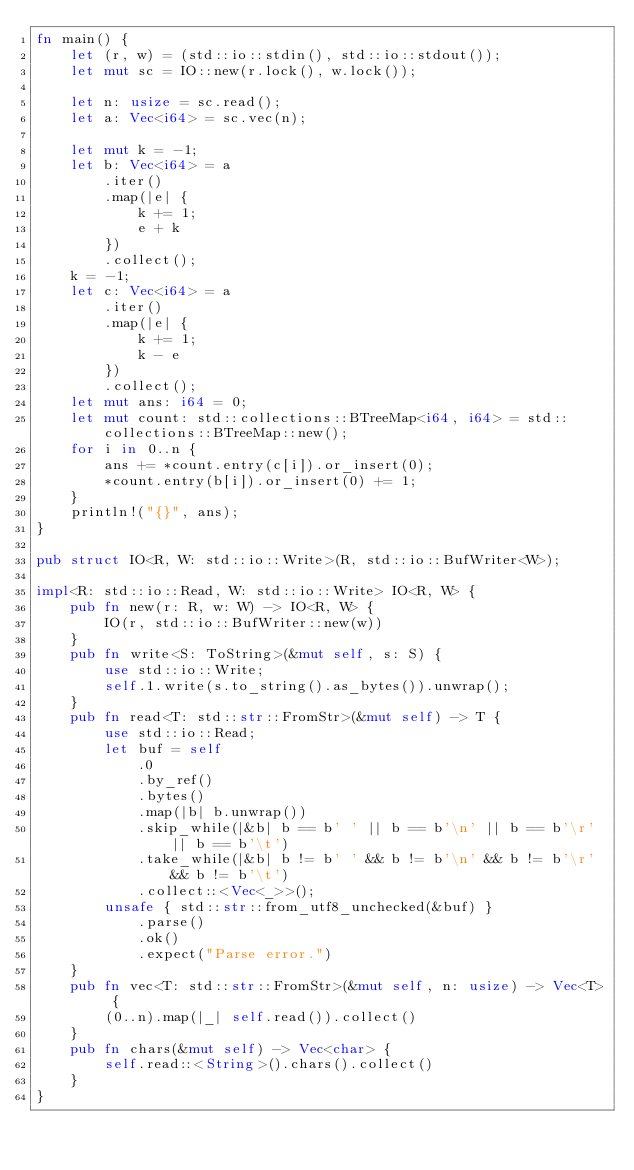<code> <loc_0><loc_0><loc_500><loc_500><_Rust_>fn main() {
    let (r, w) = (std::io::stdin(), std::io::stdout());
    let mut sc = IO::new(r.lock(), w.lock());

    let n: usize = sc.read();
    let a: Vec<i64> = sc.vec(n);

    let mut k = -1;
    let b: Vec<i64> = a
        .iter()
        .map(|e| {
            k += 1;
            e + k
        })
        .collect();
    k = -1;
    let c: Vec<i64> = a
        .iter()
        .map(|e| {
            k += 1;
            k - e
        })
        .collect();
    let mut ans: i64 = 0;
    let mut count: std::collections::BTreeMap<i64, i64> = std::collections::BTreeMap::new();
    for i in 0..n {
        ans += *count.entry(c[i]).or_insert(0);
        *count.entry(b[i]).or_insert(0) += 1;
    }
    println!("{}", ans);
}

pub struct IO<R, W: std::io::Write>(R, std::io::BufWriter<W>);

impl<R: std::io::Read, W: std::io::Write> IO<R, W> {
    pub fn new(r: R, w: W) -> IO<R, W> {
        IO(r, std::io::BufWriter::new(w))
    }
    pub fn write<S: ToString>(&mut self, s: S) {
        use std::io::Write;
        self.1.write(s.to_string().as_bytes()).unwrap();
    }
    pub fn read<T: std::str::FromStr>(&mut self) -> T {
        use std::io::Read;
        let buf = self
            .0
            .by_ref()
            .bytes()
            .map(|b| b.unwrap())
            .skip_while(|&b| b == b' ' || b == b'\n' || b == b'\r' || b == b'\t')
            .take_while(|&b| b != b' ' && b != b'\n' && b != b'\r' && b != b'\t')
            .collect::<Vec<_>>();
        unsafe { std::str::from_utf8_unchecked(&buf) }
            .parse()
            .ok()
            .expect("Parse error.")
    }
    pub fn vec<T: std::str::FromStr>(&mut self, n: usize) -> Vec<T> {
        (0..n).map(|_| self.read()).collect()
    }
    pub fn chars(&mut self) -> Vec<char> {
        self.read::<String>().chars().collect()
    }
}</code> 